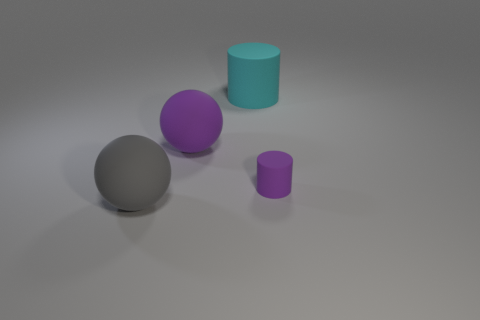Are there any large matte objects that have the same color as the small cylinder? Yes, the large sphere appears to have the same matte finish and color as the small cylinder, both exhibiting a similar hue of purple in this image. 